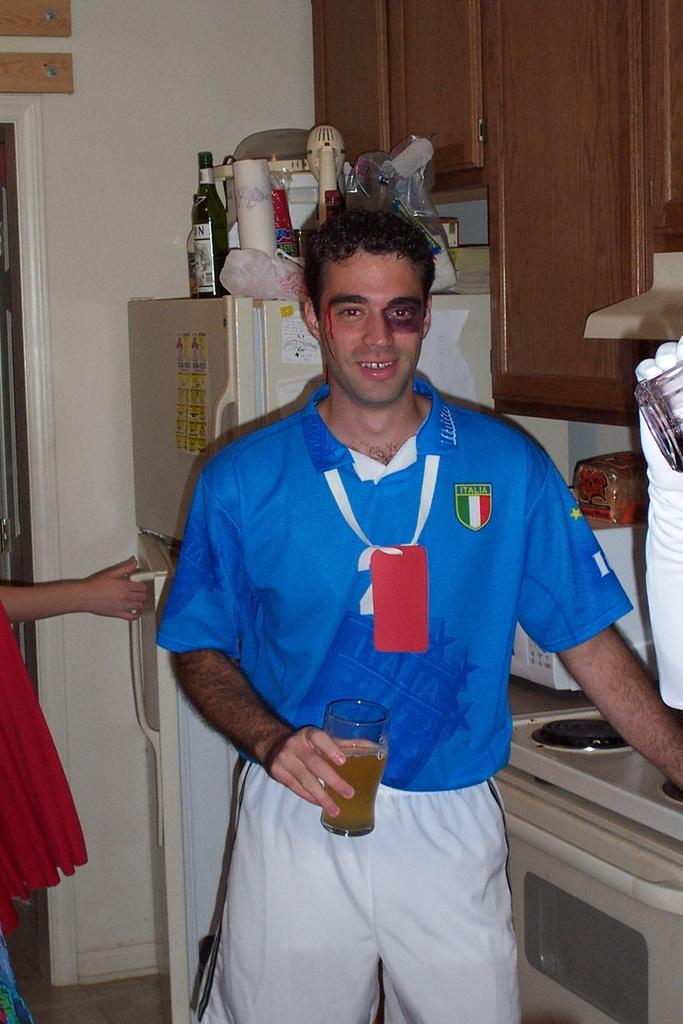Provide a one-sentence caption for the provided image. Man with a black eye wearing a shirt with Italia on left side of chest. 